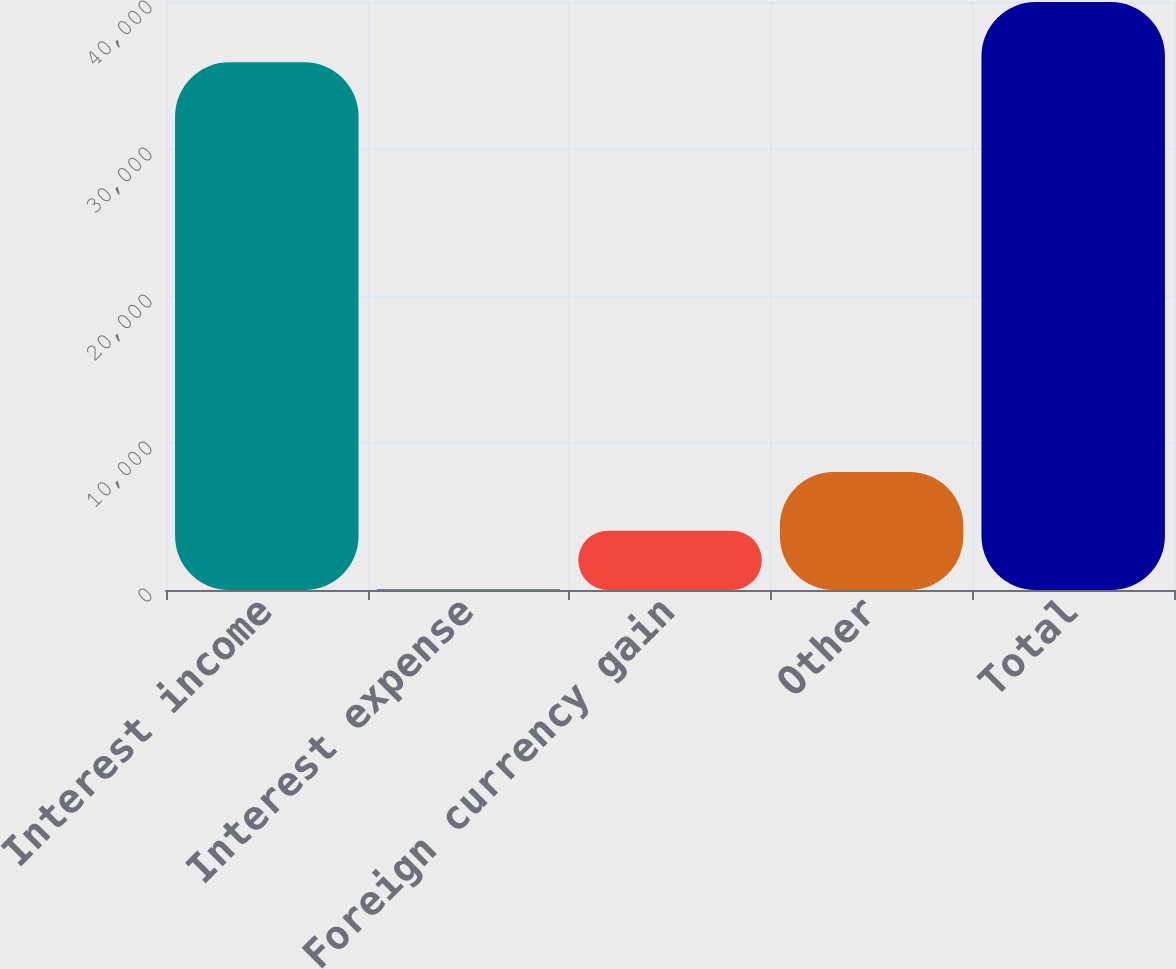<chart> <loc_0><loc_0><loc_500><loc_500><bar_chart><fcel>Interest income<fcel>Interest expense<fcel>Foreign currency gain<fcel>Other<fcel>Total<nl><fcel>35897<fcel>41<fcel>4036.4<fcel>8031.8<fcel>39995<nl></chart> 